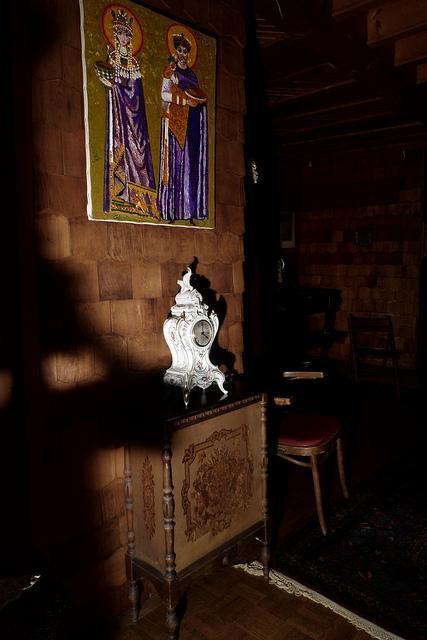How many pictures are in this photo?
Give a very brief answer. 1. How many chairs are in the picture?
Give a very brief answer. 2. How many books are stacked up?
Give a very brief answer. 0. 